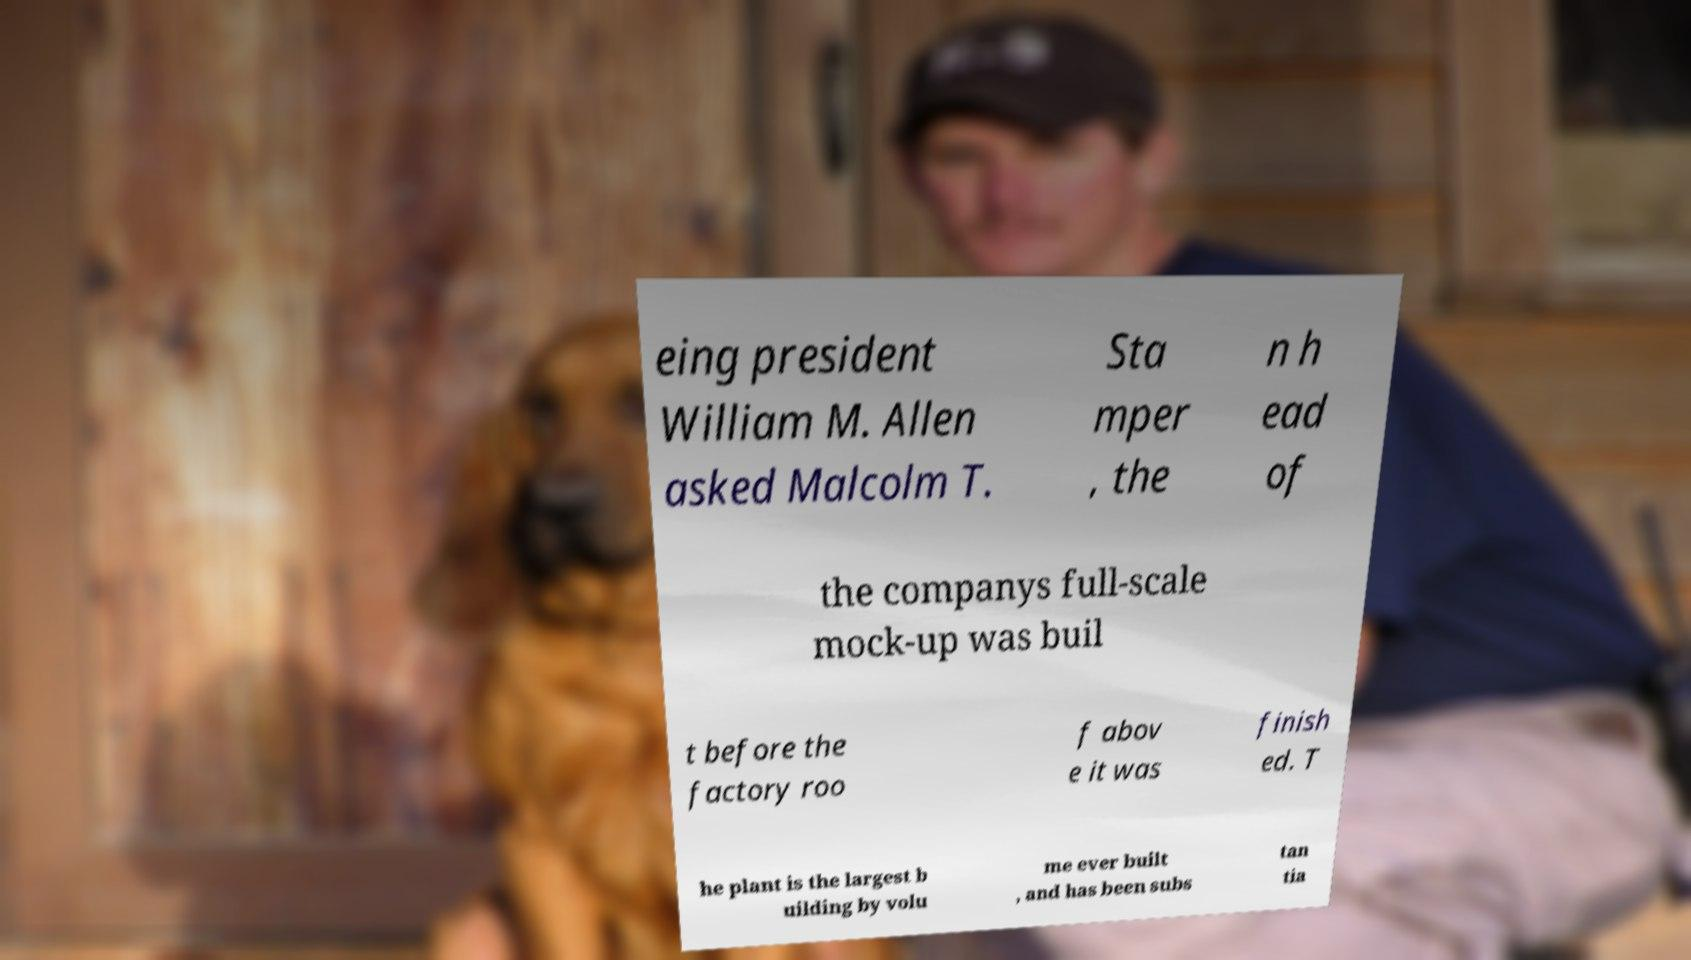Please identify and transcribe the text found in this image. eing president William M. Allen asked Malcolm T. Sta mper , the n h ead of the companys full-scale mock-up was buil t before the factory roo f abov e it was finish ed. T he plant is the largest b uilding by volu me ever built , and has been subs tan tia 